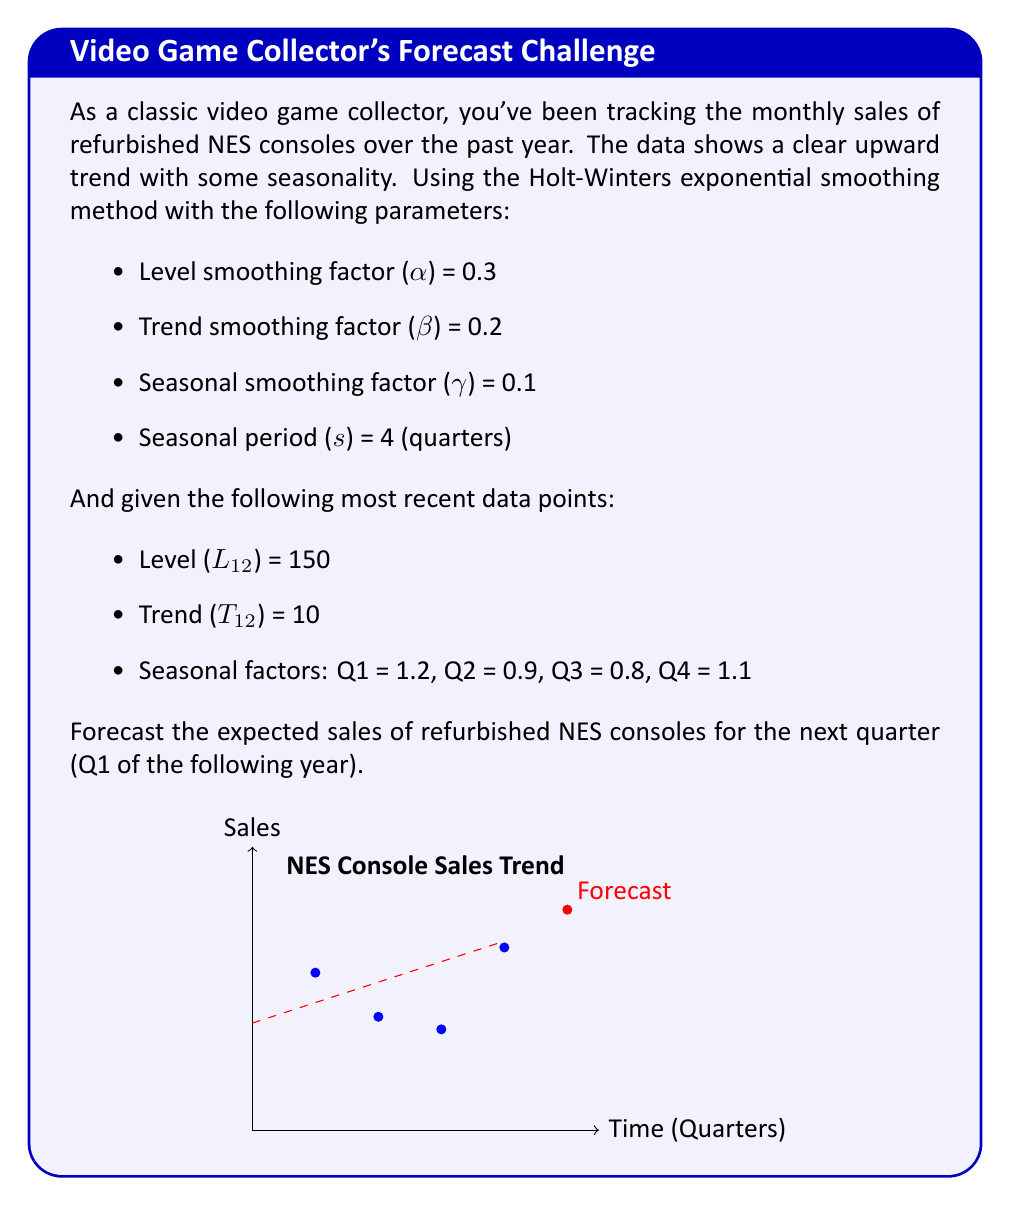Show me your answer to this math problem. To forecast the sales for the next quarter using the Holt-Winters method, we need to calculate the level, trend, and seasonal components, then combine them for the final forecast.

Step 1: Calculate the level component (L₁₃)
$$L₁₃ = α(Y₁₃/S₉) + (1-α)(L₁₂ + T₁₂)$$
Where Y₁₃/S₉ is not available, so we use the second term:
$$L₁₃ = (1-0.3)(150 + 10) = 0.7 * 160 = 112$$

Step 2: Calculate the trend component (T₁₃)
$$T₁₃ = β(L₁₃ - L₁₂) + (1-β)T₁₂$$
$$T₁₃ = 0.2(112 - 150) + (1-0.2)10 = -7.6 + 8 = 0.4$$

Step 3: The seasonal factor for Q1 is already given as 1.2

Step 4: Calculate the forecast for the next quarter (m=1 period ahead)
$$F₁₄ = (L₁₃ + mT₁₃) * S₁₃-s+m$$
$$F₁₄ = (112 + 1*0.4) * 1.2$$
$$F₁₄ = 112.4 * 1.2 = 134.88$$

Therefore, the forecast for refurbished NES console sales in the next quarter (Q1) is approximately 135 units.
Answer: 135 units 